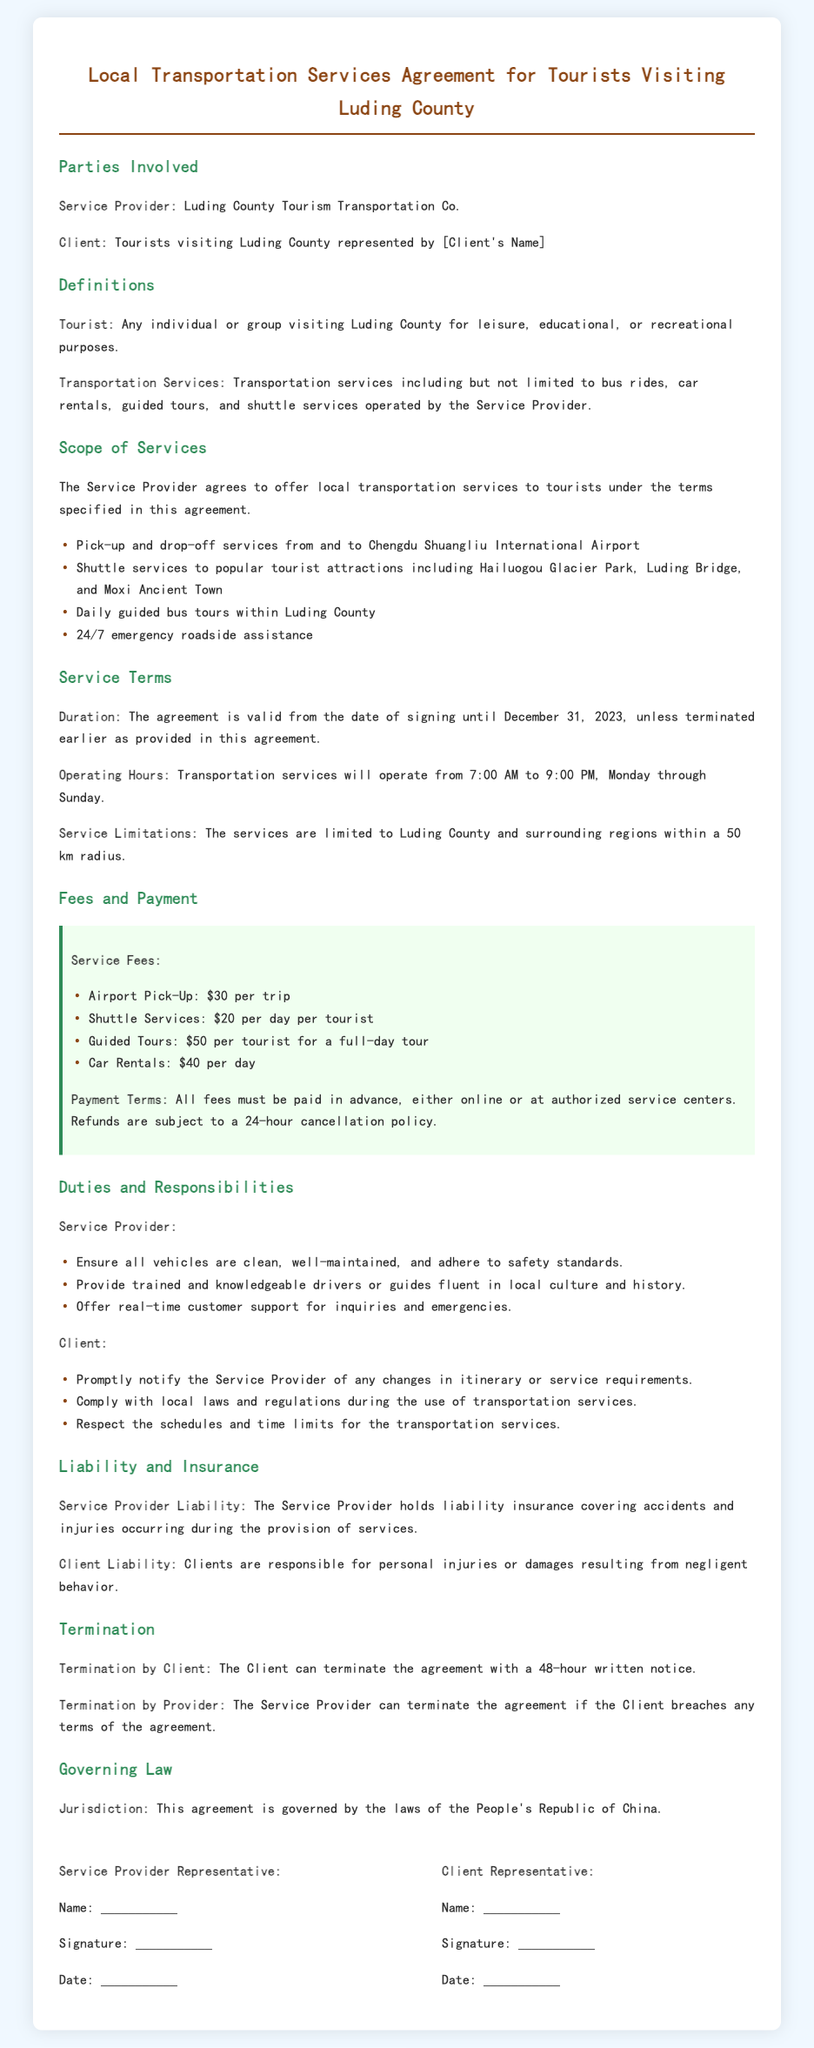what is the name of the service provider? The name of the service provider is mentioned in the document as Luding County Tourism Transportation Co.
Answer: Luding County Tourism Transportation Co what is the cost of a guided tour per tourist? The cost of a guided tour per tourist is specified in the fees section of the document.
Answer: $50 what is the operating hours for transportation services? The operating hours are clearly stated in the service terms of the document.
Answer: 7:00 AM to 9:00 PM what is required for the client to terminate the agreement? The document outlines the requirement for the client to terminate the agreement which mentions a notice period.
Answer: 48-hour written notice what types of transportation services are included? The services provided are listed in the scope of services section of the document.
Answer: Bus rides, car rentals, guided tours, shuttle services what is the liability of the service provider? The liability of the service provider is specified in the liability and insurance section.
Answer: Liability insurance covering accidents and injuries what is the cancellation policy for refunds? The document states the conditions under which refunds are processed.
Answer: 24-hour cancellation policy what is the jurisdiction governing this agreement? The jurisdiction is mentioned in the governing law section of the document.
Answer: People's Republic of China 